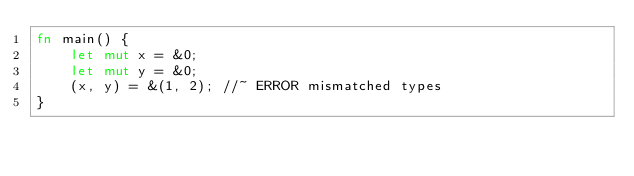Convert code to text. <code><loc_0><loc_0><loc_500><loc_500><_Rust_>fn main() {
    let mut x = &0;
    let mut y = &0;
    (x, y) = &(1, 2); //~ ERROR mismatched types
}
</code> 